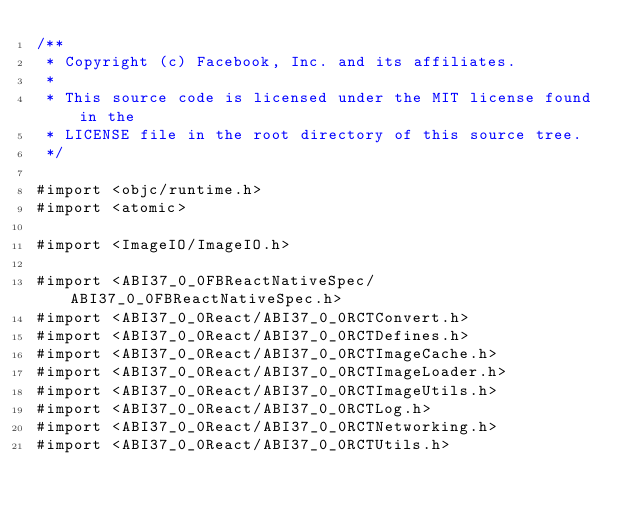<code> <loc_0><loc_0><loc_500><loc_500><_ObjectiveC_>/**
 * Copyright (c) Facebook, Inc. and its affiliates.
 *
 * This source code is licensed under the MIT license found in the
 * LICENSE file in the root directory of this source tree.
 */

#import <objc/runtime.h>
#import <atomic>

#import <ImageIO/ImageIO.h>

#import <ABI37_0_0FBReactNativeSpec/ABI37_0_0FBReactNativeSpec.h>
#import <ABI37_0_0React/ABI37_0_0RCTConvert.h>
#import <ABI37_0_0React/ABI37_0_0RCTDefines.h>
#import <ABI37_0_0React/ABI37_0_0RCTImageCache.h>
#import <ABI37_0_0React/ABI37_0_0RCTImageLoader.h>
#import <ABI37_0_0React/ABI37_0_0RCTImageUtils.h>
#import <ABI37_0_0React/ABI37_0_0RCTLog.h>
#import <ABI37_0_0React/ABI37_0_0RCTNetworking.h>
#import <ABI37_0_0React/ABI37_0_0RCTUtils.h>
</code> 